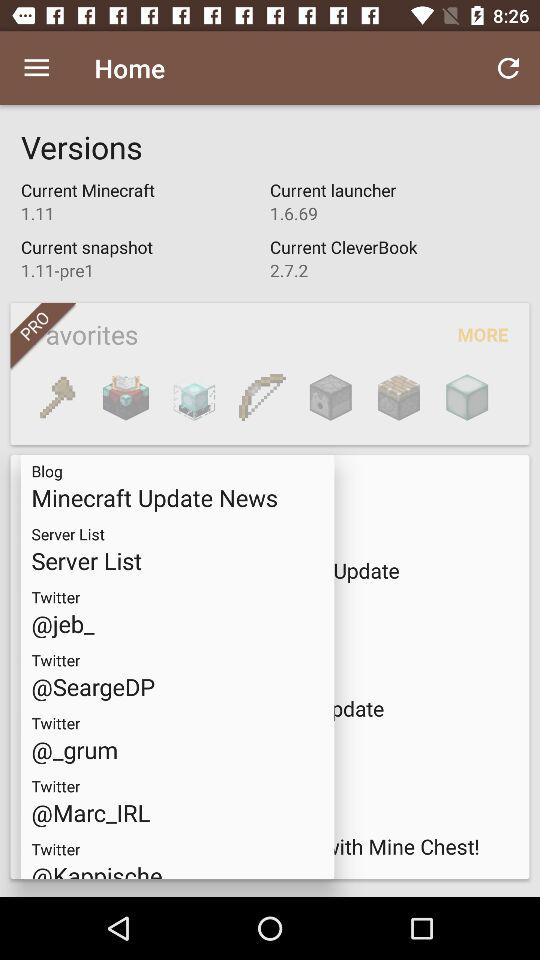How many versions are available?
Answer the question using a single word or phrase. 4 